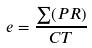Convert formula to latex. <formula><loc_0><loc_0><loc_500><loc_500>e = \frac { \sum ( P R ) } { C T }</formula> 